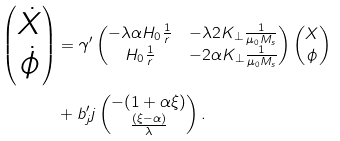Convert formula to latex. <formula><loc_0><loc_0><loc_500><loc_500>\left ( \begin{matrix} \dot { X } \\ \dot { \phi } \\ \end{matrix} \right ) & = \gamma ^ { \prime } \left ( \begin{matrix} - \lambda \alpha H _ { 0 } \frac { 1 } { r } & - \lambda 2 K _ { \perp } \frac { 1 } { \mu _ { 0 } M _ { s } } \\ H _ { 0 } \frac { 1 } { r } & - 2 \alpha K _ { \perp } \frac { 1 } { \mu _ { 0 } M _ { s } } \\ \end{matrix} \right ) \left ( \begin{matrix} X \\ \phi \\ \end{matrix} \right ) \\ & + b _ { j } ^ { \prime } j \left ( \begin{matrix} - ( 1 + \alpha \xi ) \\ \frac { ( \xi - \alpha ) } { \lambda } \\ \end{matrix} \right ) . \\</formula> 